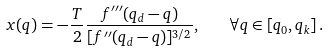Convert formula to latex. <formula><loc_0><loc_0><loc_500><loc_500>x ( q ) = - \frac { T } { 2 } \frac { f ^ { \prime \prime \prime } ( q _ { d } - q ) } { [ f ^ { \prime \prime } ( q _ { d } - q ) ] ^ { 3 / 2 } } , \quad \forall q \in [ q _ { 0 } , q _ { k } ] \, .</formula> 